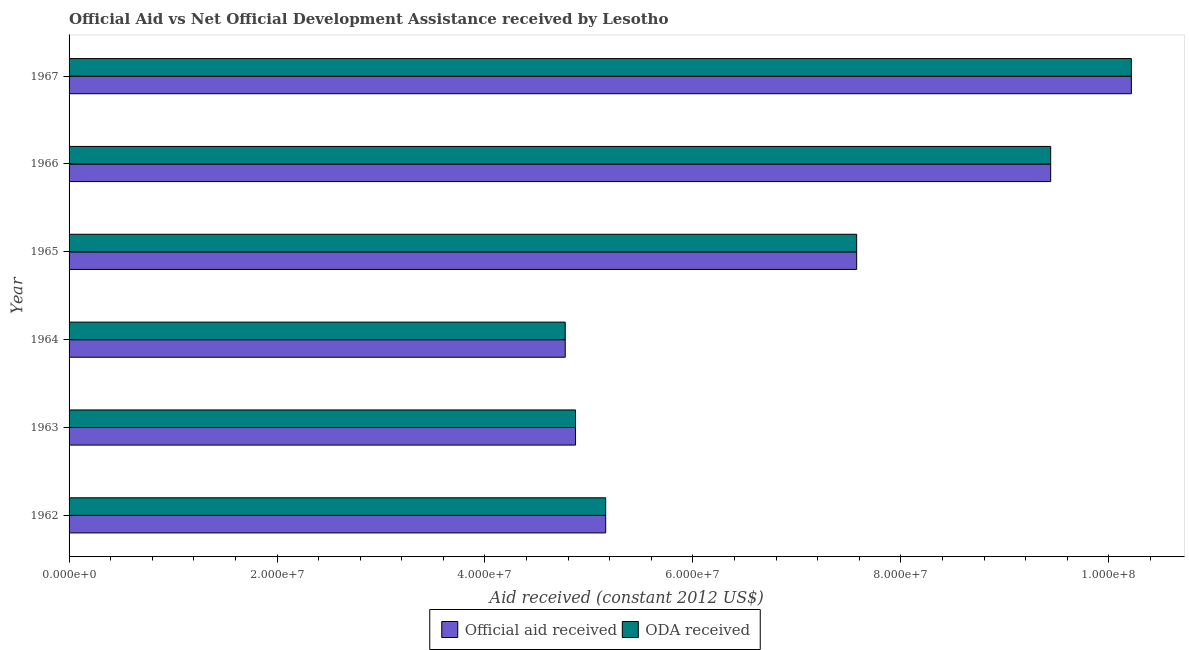How many groups of bars are there?
Your response must be concise. 6. Are the number of bars per tick equal to the number of legend labels?
Your answer should be compact. Yes. How many bars are there on the 4th tick from the top?
Give a very brief answer. 2. What is the label of the 4th group of bars from the top?
Provide a succinct answer. 1964. What is the oda received in 1962?
Keep it short and to the point. 5.16e+07. Across all years, what is the maximum oda received?
Your answer should be compact. 1.02e+08. Across all years, what is the minimum oda received?
Ensure brevity in your answer.  4.77e+07. In which year was the official aid received maximum?
Offer a terse response. 1967. In which year was the oda received minimum?
Ensure brevity in your answer.  1964. What is the total official aid received in the graph?
Offer a very short reply. 4.20e+08. What is the difference between the oda received in 1962 and that in 1965?
Make the answer very short. -2.41e+07. What is the difference between the official aid received in 1962 and the oda received in 1966?
Your response must be concise. -4.28e+07. What is the average oda received per year?
Offer a very short reply. 7.01e+07. What is the ratio of the official aid received in 1964 to that in 1965?
Your answer should be very brief. 0.63. Is the oda received in 1963 less than that in 1965?
Provide a short and direct response. Yes. What is the difference between the highest and the second highest official aid received?
Give a very brief answer. 7.76e+06. What is the difference between the highest and the lowest oda received?
Keep it short and to the point. 5.44e+07. In how many years, is the oda received greater than the average oda received taken over all years?
Provide a short and direct response. 3. Is the sum of the oda received in 1964 and 1966 greater than the maximum official aid received across all years?
Provide a succinct answer. Yes. What does the 1st bar from the top in 1966 represents?
Provide a short and direct response. ODA received. What does the 1st bar from the bottom in 1965 represents?
Provide a short and direct response. Official aid received. How many bars are there?
Provide a succinct answer. 12. Are the values on the major ticks of X-axis written in scientific E-notation?
Your response must be concise. Yes. Does the graph contain any zero values?
Provide a short and direct response. No. Does the graph contain grids?
Keep it short and to the point. No. Where does the legend appear in the graph?
Provide a short and direct response. Bottom center. How are the legend labels stacked?
Ensure brevity in your answer.  Horizontal. What is the title of the graph?
Your answer should be compact. Official Aid vs Net Official Development Assistance received by Lesotho . What is the label or title of the X-axis?
Provide a succinct answer. Aid received (constant 2012 US$). What is the label or title of the Y-axis?
Provide a short and direct response. Year. What is the Aid received (constant 2012 US$) in Official aid received in 1962?
Your response must be concise. 5.16e+07. What is the Aid received (constant 2012 US$) of ODA received in 1962?
Keep it short and to the point. 5.16e+07. What is the Aid received (constant 2012 US$) in Official aid received in 1963?
Your answer should be very brief. 4.87e+07. What is the Aid received (constant 2012 US$) in ODA received in 1963?
Offer a very short reply. 4.87e+07. What is the Aid received (constant 2012 US$) of Official aid received in 1964?
Ensure brevity in your answer.  4.77e+07. What is the Aid received (constant 2012 US$) in ODA received in 1964?
Provide a succinct answer. 4.77e+07. What is the Aid received (constant 2012 US$) of Official aid received in 1965?
Provide a short and direct response. 7.58e+07. What is the Aid received (constant 2012 US$) of ODA received in 1965?
Your response must be concise. 7.58e+07. What is the Aid received (constant 2012 US$) of Official aid received in 1966?
Your answer should be very brief. 9.44e+07. What is the Aid received (constant 2012 US$) in ODA received in 1966?
Your answer should be compact. 9.44e+07. What is the Aid received (constant 2012 US$) in Official aid received in 1967?
Offer a very short reply. 1.02e+08. What is the Aid received (constant 2012 US$) of ODA received in 1967?
Ensure brevity in your answer.  1.02e+08. Across all years, what is the maximum Aid received (constant 2012 US$) in Official aid received?
Offer a terse response. 1.02e+08. Across all years, what is the maximum Aid received (constant 2012 US$) of ODA received?
Give a very brief answer. 1.02e+08. Across all years, what is the minimum Aid received (constant 2012 US$) of Official aid received?
Your answer should be very brief. 4.77e+07. Across all years, what is the minimum Aid received (constant 2012 US$) of ODA received?
Make the answer very short. 4.77e+07. What is the total Aid received (constant 2012 US$) of Official aid received in the graph?
Provide a short and direct response. 4.20e+08. What is the total Aid received (constant 2012 US$) of ODA received in the graph?
Offer a terse response. 4.20e+08. What is the difference between the Aid received (constant 2012 US$) in Official aid received in 1962 and that in 1963?
Your answer should be compact. 2.90e+06. What is the difference between the Aid received (constant 2012 US$) of ODA received in 1962 and that in 1963?
Provide a short and direct response. 2.90e+06. What is the difference between the Aid received (constant 2012 US$) of Official aid received in 1962 and that in 1964?
Offer a terse response. 3.89e+06. What is the difference between the Aid received (constant 2012 US$) in ODA received in 1962 and that in 1964?
Provide a succinct answer. 3.89e+06. What is the difference between the Aid received (constant 2012 US$) of Official aid received in 1962 and that in 1965?
Provide a succinct answer. -2.41e+07. What is the difference between the Aid received (constant 2012 US$) of ODA received in 1962 and that in 1965?
Keep it short and to the point. -2.41e+07. What is the difference between the Aid received (constant 2012 US$) in Official aid received in 1962 and that in 1966?
Keep it short and to the point. -4.28e+07. What is the difference between the Aid received (constant 2012 US$) in ODA received in 1962 and that in 1966?
Your answer should be very brief. -4.28e+07. What is the difference between the Aid received (constant 2012 US$) of Official aid received in 1962 and that in 1967?
Offer a terse response. -5.06e+07. What is the difference between the Aid received (constant 2012 US$) of ODA received in 1962 and that in 1967?
Provide a succinct answer. -5.06e+07. What is the difference between the Aid received (constant 2012 US$) in Official aid received in 1963 and that in 1964?
Provide a succinct answer. 9.90e+05. What is the difference between the Aid received (constant 2012 US$) of ODA received in 1963 and that in 1964?
Your answer should be compact. 9.90e+05. What is the difference between the Aid received (constant 2012 US$) in Official aid received in 1963 and that in 1965?
Ensure brevity in your answer.  -2.70e+07. What is the difference between the Aid received (constant 2012 US$) of ODA received in 1963 and that in 1965?
Your answer should be compact. -2.70e+07. What is the difference between the Aid received (constant 2012 US$) of Official aid received in 1963 and that in 1966?
Provide a succinct answer. -4.57e+07. What is the difference between the Aid received (constant 2012 US$) of ODA received in 1963 and that in 1966?
Offer a very short reply. -4.57e+07. What is the difference between the Aid received (constant 2012 US$) of Official aid received in 1963 and that in 1967?
Ensure brevity in your answer.  -5.35e+07. What is the difference between the Aid received (constant 2012 US$) of ODA received in 1963 and that in 1967?
Give a very brief answer. -5.35e+07. What is the difference between the Aid received (constant 2012 US$) of Official aid received in 1964 and that in 1965?
Ensure brevity in your answer.  -2.80e+07. What is the difference between the Aid received (constant 2012 US$) in ODA received in 1964 and that in 1965?
Offer a terse response. -2.80e+07. What is the difference between the Aid received (constant 2012 US$) in Official aid received in 1964 and that in 1966?
Make the answer very short. -4.67e+07. What is the difference between the Aid received (constant 2012 US$) of ODA received in 1964 and that in 1966?
Your response must be concise. -4.67e+07. What is the difference between the Aid received (constant 2012 US$) in Official aid received in 1964 and that in 1967?
Provide a short and direct response. -5.44e+07. What is the difference between the Aid received (constant 2012 US$) in ODA received in 1964 and that in 1967?
Ensure brevity in your answer.  -5.44e+07. What is the difference between the Aid received (constant 2012 US$) of Official aid received in 1965 and that in 1966?
Your answer should be very brief. -1.87e+07. What is the difference between the Aid received (constant 2012 US$) in ODA received in 1965 and that in 1966?
Make the answer very short. -1.87e+07. What is the difference between the Aid received (constant 2012 US$) of Official aid received in 1965 and that in 1967?
Offer a terse response. -2.64e+07. What is the difference between the Aid received (constant 2012 US$) in ODA received in 1965 and that in 1967?
Your answer should be very brief. -2.64e+07. What is the difference between the Aid received (constant 2012 US$) in Official aid received in 1966 and that in 1967?
Ensure brevity in your answer.  -7.76e+06. What is the difference between the Aid received (constant 2012 US$) of ODA received in 1966 and that in 1967?
Provide a short and direct response. -7.76e+06. What is the difference between the Aid received (constant 2012 US$) of Official aid received in 1962 and the Aid received (constant 2012 US$) of ODA received in 1963?
Offer a very short reply. 2.90e+06. What is the difference between the Aid received (constant 2012 US$) of Official aid received in 1962 and the Aid received (constant 2012 US$) of ODA received in 1964?
Provide a short and direct response. 3.89e+06. What is the difference between the Aid received (constant 2012 US$) in Official aid received in 1962 and the Aid received (constant 2012 US$) in ODA received in 1965?
Give a very brief answer. -2.41e+07. What is the difference between the Aid received (constant 2012 US$) in Official aid received in 1962 and the Aid received (constant 2012 US$) in ODA received in 1966?
Your answer should be very brief. -4.28e+07. What is the difference between the Aid received (constant 2012 US$) of Official aid received in 1962 and the Aid received (constant 2012 US$) of ODA received in 1967?
Provide a short and direct response. -5.06e+07. What is the difference between the Aid received (constant 2012 US$) in Official aid received in 1963 and the Aid received (constant 2012 US$) in ODA received in 1964?
Keep it short and to the point. 9.90e+05. What is the difference between the Aid received (constant 2012 US$) in Official aid received in 1963 and the Aid received (constant 2012 US$) in ODA received in 1965?
Make the answer very short. -2.70e+07. What is the difference between the Aid received (constant 2012 US$) of Official aid received in 1963 and the Aid received (constant 2012 US$) of ODA received in 1966?
Make the answer very short. -4.57e+07. What is the difference between the Aid received (constant 2012 US$) in Official aid received in 1963 and the Aid received (constant 2012 US$) in ODA received in 1967?
Offer a terse response. -5.35e+07. What is the difference between the Aid received (constant 2012 US$) in Official aid received in 1964 and the Aid received (constant 2012 US$) in ODA received in 1965?
Provide a succinct answer. -2.80e+07. What is the difference between the Aid received (constant 2012 US$) in Official aid received in 1964 and the Aid received (constant 2012 US$) in ODA received in 1966?
Your response must be concise. -4.67e+07. What is the difference between the Aid received (constant 2012 US$) in Official aid received in 1964 and the Aid received (constant 2012 US$) in ODA received in 1967?
Keep it short and to the point. -5.44e+07. What is the difference between the Aid received (constant 2012 US$) in Official aid received in 1965 and the Aid received (constant 2012 US$) in ODA received in 1966?
Provide a succinct answer. -1.87e+07. What is the difference between the Aid received (constant 2012 US$) of Official aid received in 1965 and the Aid received (constant 2012 US$) of ODA received in 1967?
Provide a short and direct response. -2.64e+07. What is the difference between the Aid received (constant 2012 US$) of Official aid received in 1966 and the Aid received (constant 2012 US$) of ODA received in 1967?
Your answer should be compact. -7.76e+06. What is the average Aid received (constant 2012 US$) of Official aid received per year?
Keep it short and to the point. 7.01e+07. What is the average Aid received (constant 2012 US$) of ODA received per year?
Offer a terse response. 7.01e+07. In the year 1962, what is the difference between the Aid received (constant 2012 US$) of Official aid received and Aid received (constant 2012 US$) of ODA received?
Your response must be concise. 0. In the year 1965, what is the difference between the Aid received (constant 2012 US$) of Official aid received and Aid received (constant 2012 US$) of ODA received?
Your response must be concise. 0. In the year 1966, what is the difference between the Aid received (constant 2012 US$) of Official aid received and Aid received (constant 2012 US$) of ODA received?
Provide a succinct answer. 0. In the year 1967, what is the difference between the Aid received (constant 2012 US$) in Official aid received and Aid received (constant 2012 US$) in ODA received?
Offer a very short reply. 0. What is the ratio of the Aid received (constant 2012 US$) of Official aid received in 1962 to that in 1963?
Ensure brevity in your answer.  1.06. What is the ratio of the Aid received (constant 2012 US$) in ODA received in 1962 to that in 1963?
Give a very brief answer. 1.06. What is the ratio of the Aid received (constant 2012 US$) of Official aid received in 1962 to that in 1964?
Give a very brief answer. 1.08. What is the ratio of the Aid received (constant 2012 US$) in ODA received in 1962 to that in 1964?
Keep it short and to the point. 1.08. What is the ratio of the Aid received (constant 2012 US$) of Official aid received in 1962 to that in 1965?
Offer a terse response. 0.68. What is the ratio of the Aid received (constant 2012 US$) of ODA received in 1962 to that in 1965?
Give a very brief answer. 0.68. What is the ratio of the Aid received (constant 2012 US$) in Official aid received in 1962 to that in 1966?
Provide a short and direct response. 0.55. What is the ratio of the Aid received (constant 2012 US$) of ODA received in 1962 to that in 1966?
Your answer should be very brief. 0.55. What is the ratio of the Aid received (constant 2012 US$) of Official aid received in 1962 to that in 1967?
Provide a short and direct response. 0.51. What is the ratio of the Aid received (constant 2012 US$) of ODA received in 1962 to that in 1967?
Provide a succinct answer. 0.51. What is the ratio of the Aid received (constant 2012 US$) of Official aid received in 1963 to that in 1964?
Make the answer very short. 1.02. What is the ratio of the Aid received (constant 2012 US$) of ODA received in 1963 to that in 1964?
Offer a very short reply. 1.02. What is the ratio of the Aid received (constant 2012 US$) of Official aid received in 1963 to that in 1965?
Your response must be concise. 0.64. What is the ratio of the Aid received (constant 2012 US$) of ODA received in 1963 to that in 1965?
Keep it short and to the point. 0.64. What is the ratio of the Aid received (constant 2012 US$) in Official aid received in 1963 to that in 1966?
Keep it short and to the point. 0.52. What is the ratio of the Aid received (constant 2012 US$) in ODA received in 1963 to that in 1966?
Your answer should be compact. 0.52. What is the ratio of the Aid received (constant 2012 US$) of Official aid received in 1963 to that in 1967?
Your response must be concise. 0.48. What is the ratio of the Aid received (constant 2012 US$) in ODA received in 1963 to that in 1967?
Make the answer very short. 0.48. What is the ratio of the Aid received (constant 2012 US$) in Official aid received in 1964 to that in 1965?
Offer a terse response. 0.63. What is the ratio of the Aid received (constant 2012 US$) in ODA received in 1964 to that in 1965?
Provide a short and direct response. 0.63. What is the ratio of the Aid received (constant 2012 US$) in Official aid received in 1964 to that in 1966?
Make the answer very short. 0.51. What is the ratio of the Aid received (constant 2012 US$) of ODA received in 1964 to that in 1966?
Give a very brief answer. 0.51. What is the ratio of the Aid received (constant 2012 US$) of Official aid received in 1964 to that in 1967?
Keep it short and to the point. 0.47. What is the ratio of the Aid received (constant 2012 US$) in ODA received in 1964 to that in 1967?
Ensure brevity in your answer.  0.47. What is the ratio of the Aid received (constant 2012 US$) of Official aid received in 1965 to that in 1966?
Give a very brief answer. 0.8. What is the ratio of the Aid received (constant 2012 US$) of ODA received in 1965 to that in 1966?
Ensure brevity in your answer.  0.8. What is the ratio of the Aid received (constant 2012 US$) of Official aid received in 1965 to that in 1967?
Offer a terse response. 0.74. What is the ratio of the Aid received (constant 2012 US$) in ODA received in 1965 to that in 1967?
Provide a succinct answer. 0.74. What is the ratio of the Aid received (constant 2012 US$) in Official aid received in 1966 to that in 1967?
Your response must be concise. 0.92. What is the ratio of the Aid received (constant 2012 US$) of ODA received in 1966 to that in 1967?
Give a very brief answer. 0.92. What is the difference between the highest and the second highest Aid received (constant 2012 US$) in Official aid received?
Your response must be concise. 7.76e+06. What is the difference between the highest and the second highest Aid received (constant 2012 US$) of ODA received?
Your answer should be compact. 7.76e+06. What is the difference between the highest and the lowest Aid received (constant 2012 US$) in Official aid received?
Your answer should be compact. 5.44e+07. What is the difference between the highest and the lowest Aid received (constant 2012 US$) of ODA received?
Keep it short and to the point. 5.44e+07. 